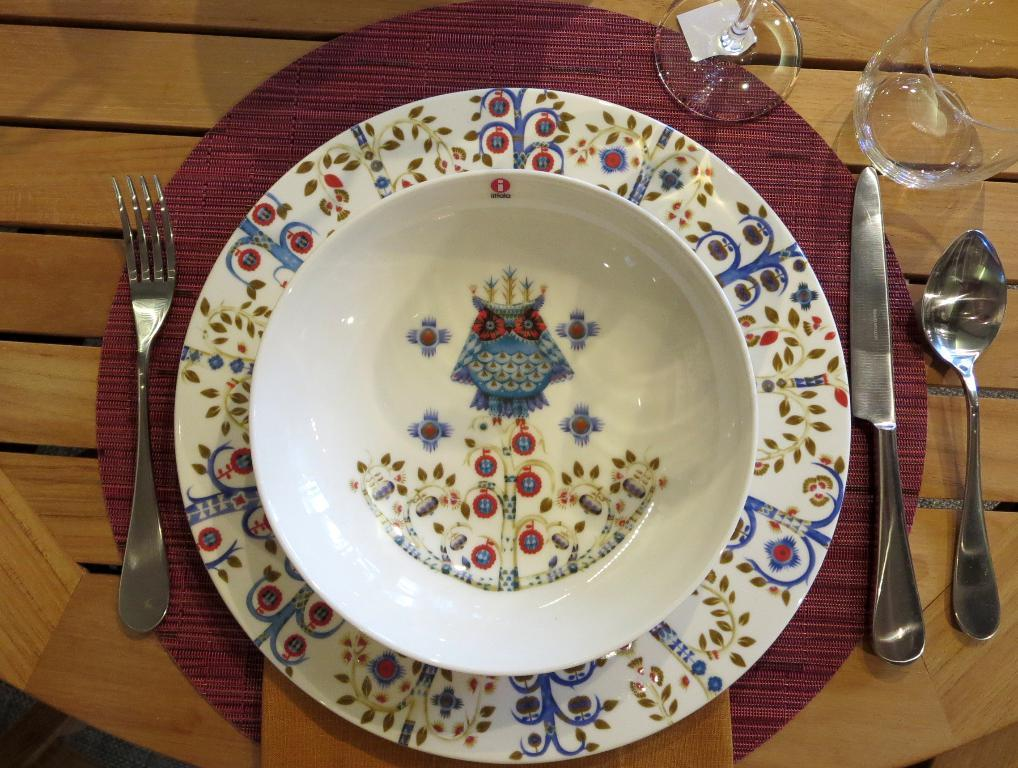What is present on the table in the image? There is a plate, a knife, a spoon, two glasses, and a fork in the image. What material is the table made of? The table is made of wood. How many icicles are hanging from the glasses in the image? There are no icicles present in the image; it features a table with various utensils and glasses. What type of beds can be seen in the image? There are no beds present in the image; it features a table with various utensils and glasses. 